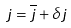Convert formula to latex. <formula><loc_0><loc_0><loc_500><loc_500>j = \overline { j } + \delta j</formula> 